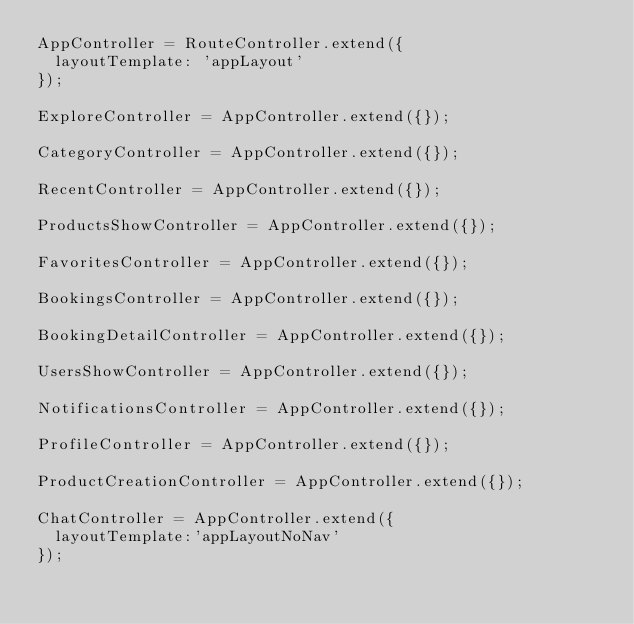<code> <loc_0><loc_0><loc_500><loc_500><_JavaScript_>AppController = RouteController.extend({
  layoutTemplate: 'appLayout'
});

ExploreController = AppController.extend({});

CategoryController = AppController.extend({});

RecentController = AppController.extend({});

ProductsShowController = AppController.extend({});

FavoritesController = AppController.extend({});

BookingsController = AppController.extend({});

BookingDetailController = AppController.extend({});

UsersShowController = AppController.extend({});

NotificationsController = AppController.extend({});

ProfileController = AppController.extend({});

ProductCreationController = AppController.extend({});

ChatController = AppController.extend({
  layoutTemplate:'appLayoutNoNav'
});</code> 